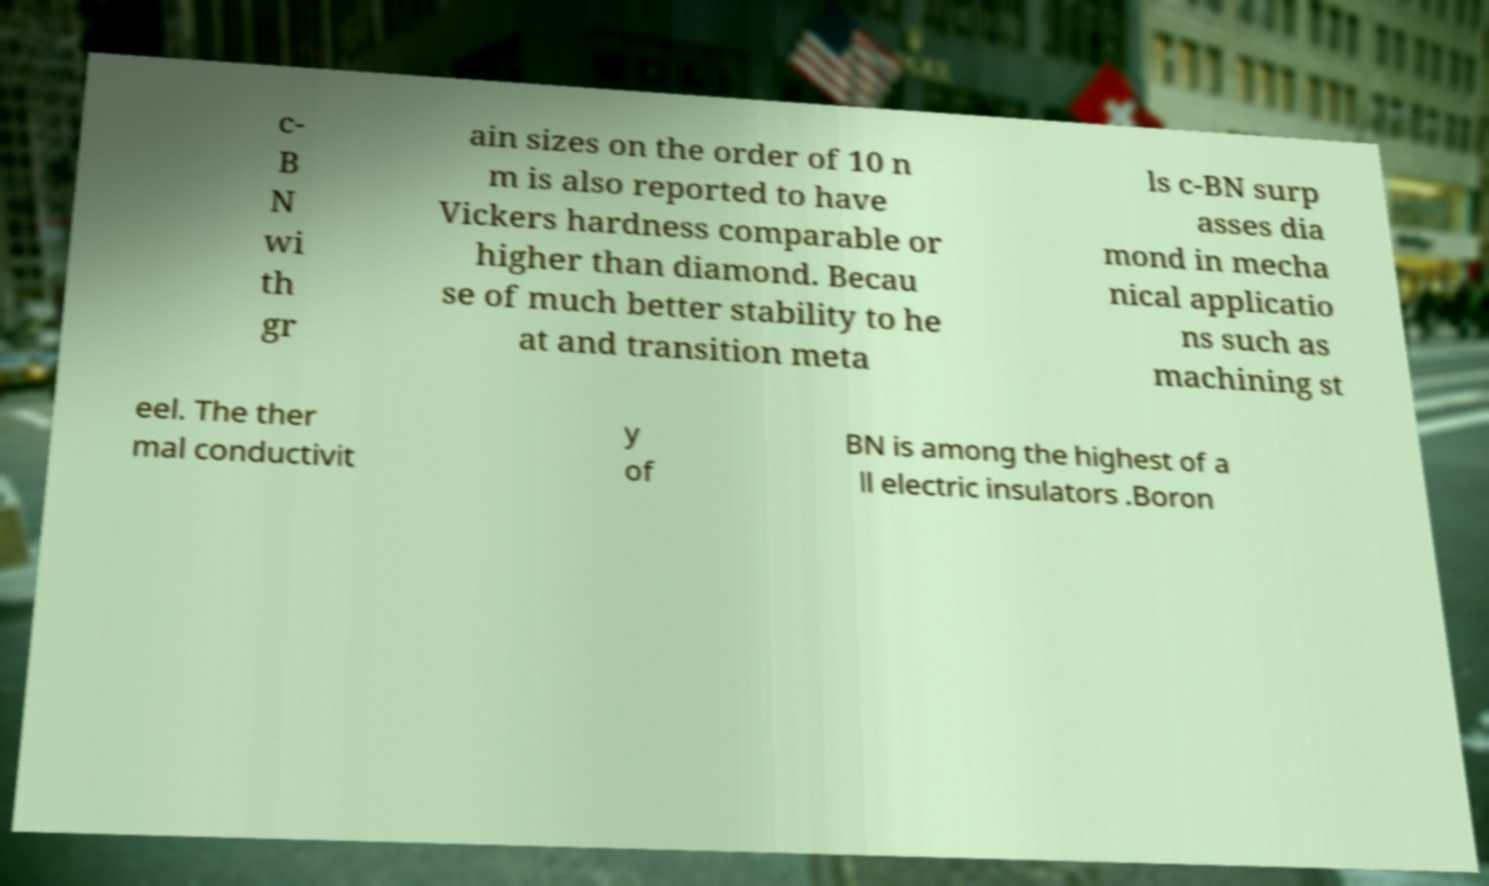What messages or text are displayed in this image? I need them in a readable, typed format. c- B N wi th gr ain sizes on the order of 10 n m is also reported to have Vickers hardness comparable or higher than diamond. Becau se of much better stability to he at and transition meta ls c-BN surp asses dia mond in mecha nical applicatio ns such as machining st eel. The ther mal conductivit y of BN is among the highest of a ll electric insulators .Boron 